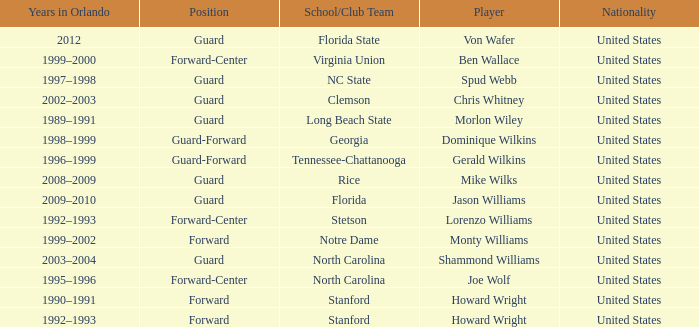Can you parse all the data within this table? {'header': ['Years in Orlando', 'Position', 'School/Club Team', 'Player', 'Nationality'], 'rows': [['2012', 'Guard', 'Florida State', 'Von Wafer', 'United States'], ['1999–2000', 'Forward-Center', 'Virginia Union', 'Ben Wallace', 'United States'], ['1997–1998', 'Guard', 'NC State', 'Spud Webb', 'United States'], ['2002–2003', 'Guard', 'Clemson', 'Chris Whitney', 'United States'], ['1989–1991', 'Guard', 'Long Beach State', 'Morlon Wiley', 'United States'], ['1998–1999', 'Guard-Forward', 'Georgia', 'Dominique Wilkins', 'United States'], ['1996–1999', 'Guard-Forward', 'Tennessee-Chattanooga', 'Gerald Wilkins', 'United States'], ['2008–2009', 'Guard', 'Rice', 'Mike Wilks', 'United States'], ['2009–2010', 'Guard', 'Florida', 'Jason Williams', 'United States'], ['1992–1993', 'Forward-Center', 'Stetson', 'Lorenzo Williams', 'United States'], ['1999–2002', 'Forward', 'Notre Dame', 'Monty Williams', 'United States'], ['2003–2004', 'Guard', 'North Carolina', 'Shammond Williams', 'United States'], ['1995–1996', 'Forward-Center', 'North Carolina', 'Joe Wolf', 'United States'], ['1990–1991', 'Forward', 'Stanford', 'Howard Wright', 'United States'], ['1992–1993', 'Forward', 'Stanford', 'Howard Wright', 'United States']]} What School/Club did Dominique Wilkins play for? Georgia. 